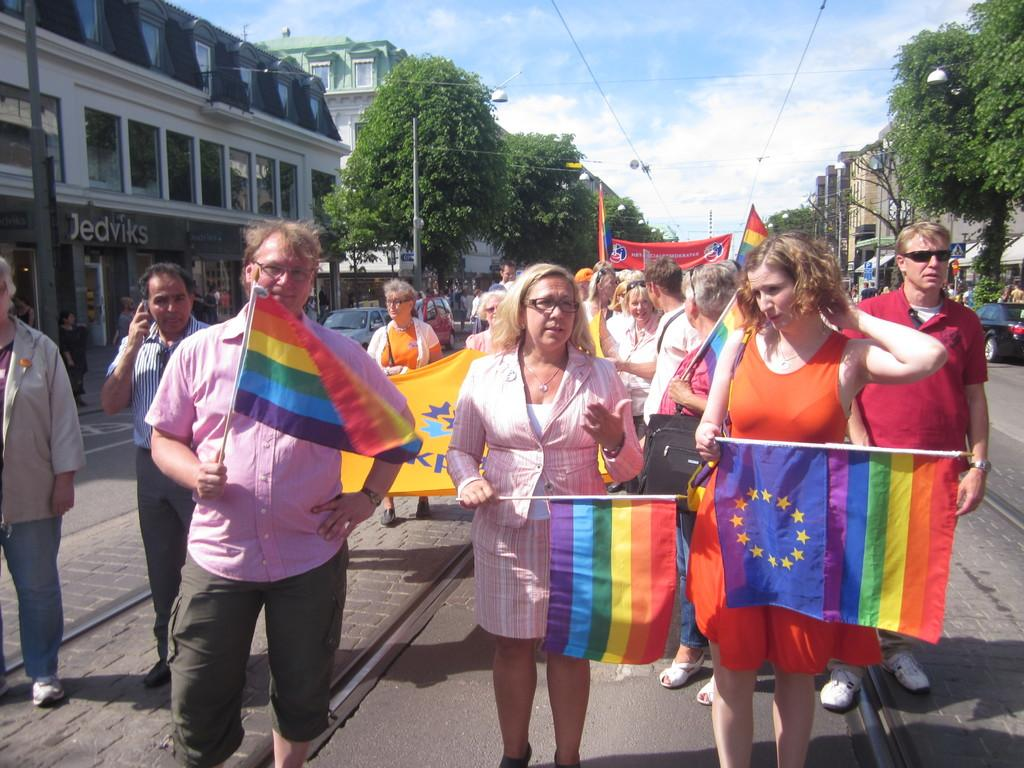What are the people in the image doing? The people in the image are standing and holding a flag. What can be seen in the background of the image? There are trees and buildings in the image. Are there any vehicles visible in the image? Yes, there are cars in the image. What type of humor can be seen on the people's hair in the image? There is no humor or hair visible on the people in the image; they are holding a flag. What type of linen is draped over the trees in the image? There is no linen present in the image; it features people holding a flag, trees, buildings, and cars. 